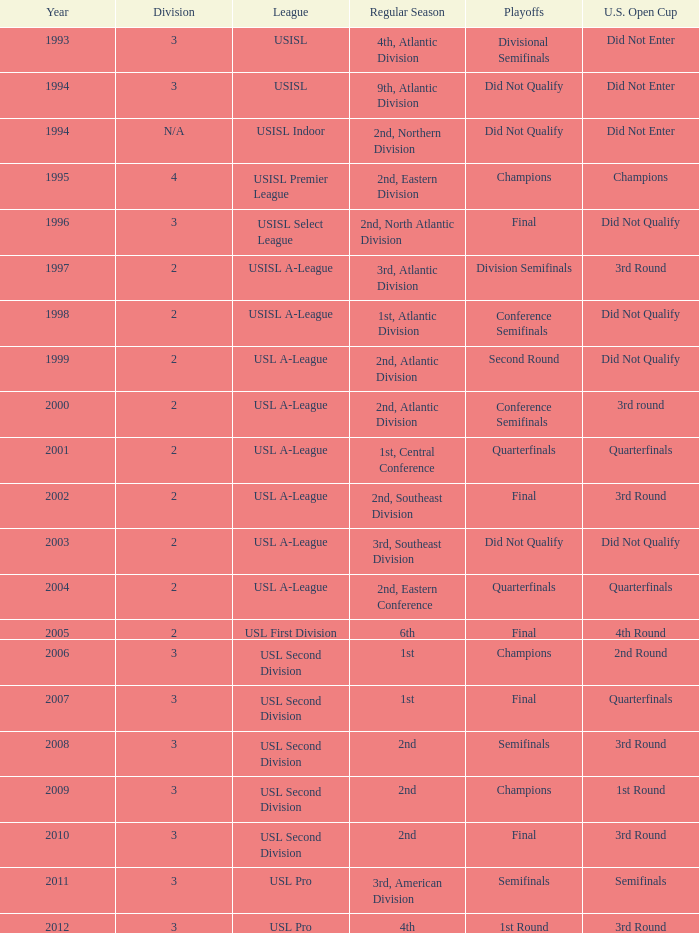At what stage is the u.s. open cup division semi-finals? 3rd Round. 